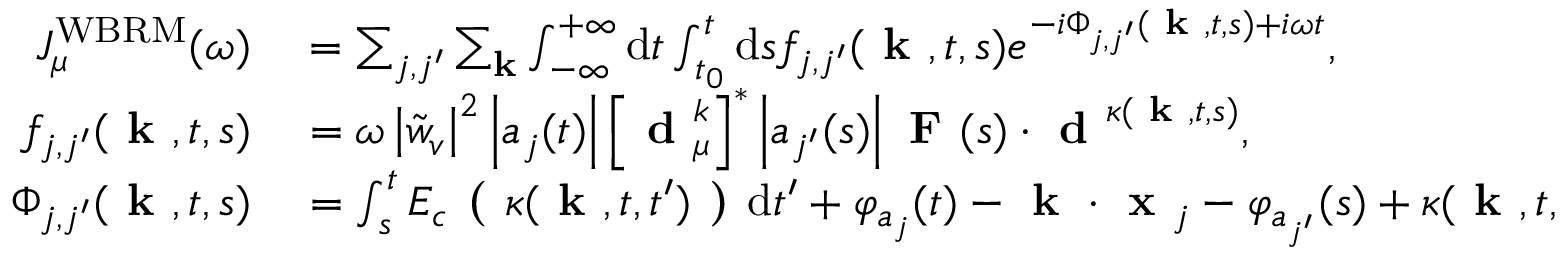<formula> <loc_0><loc_0><loc_500><loc_500>\begin{array} { r l } { J _ { \mu } ^ { W B R M } ( \omega ) } & = \sum _ { j , j ^ { \prime } } \sum _ { k } \int _ { - \infty } ^ { + \infty } d t \int _ { t _ { 0 } } ^ { t } d s f _ { j , j ^ { \prime } } ( k , t , s ) e ^ { - i \Phi _ { j , j ^ { \prime } } ( k , t , s ) + i \omega t } , } \\ { f _ { j , j ^ { \prime } } ( k , t , s ) } & = \omega \left | \tilde { w } _ { v } \right | ^ { 2 } \left | a _ { j } ( t ) \right | \left [ d _ { \mu } ^ { k } \right ] ^ { * } \left | a _ { j ^ { \prime } } ( s ) \right | F ( s ) \cdot d ^ { \kappa ( k , t , s ) } , } \\ { \Phi _ { j , j ^ { \prime } } ( k , t , s ) } & = \int _ { s } ^ { t } E _ { c } ( \kappa ( k , t , t ^ { \prime } ) ) d t ^ { \prime } + \varphi _ { a _ { j } } ( t ) - k \cdot x _ { j } - \varphi _ { a _ { j ^ { \prime } } } ( s ) + \kappa ( k , t , s ) \cdot x _ { j ^ { \prime } } } \end{array}</formula> 